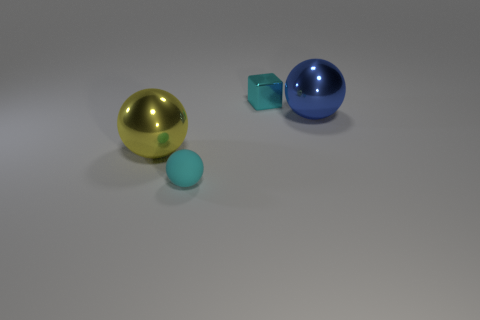Add 4 big metallic balls. How many objects exist? 8 Subtract all blocks. How many objects are left? 3 Subtract all blue shiny things. Subtract all blocks. How many objects are left? 2 Add 1 cyan balls. How many cyan balls are left? 2 Add 2 cyan metal blocks. How many cyan metal blocks exist? 3 Subtract 0 green cubes. How many objects are left? 4 